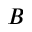<formula> <loc_0><loc_0><loc_500><loc_500>B</formula> 